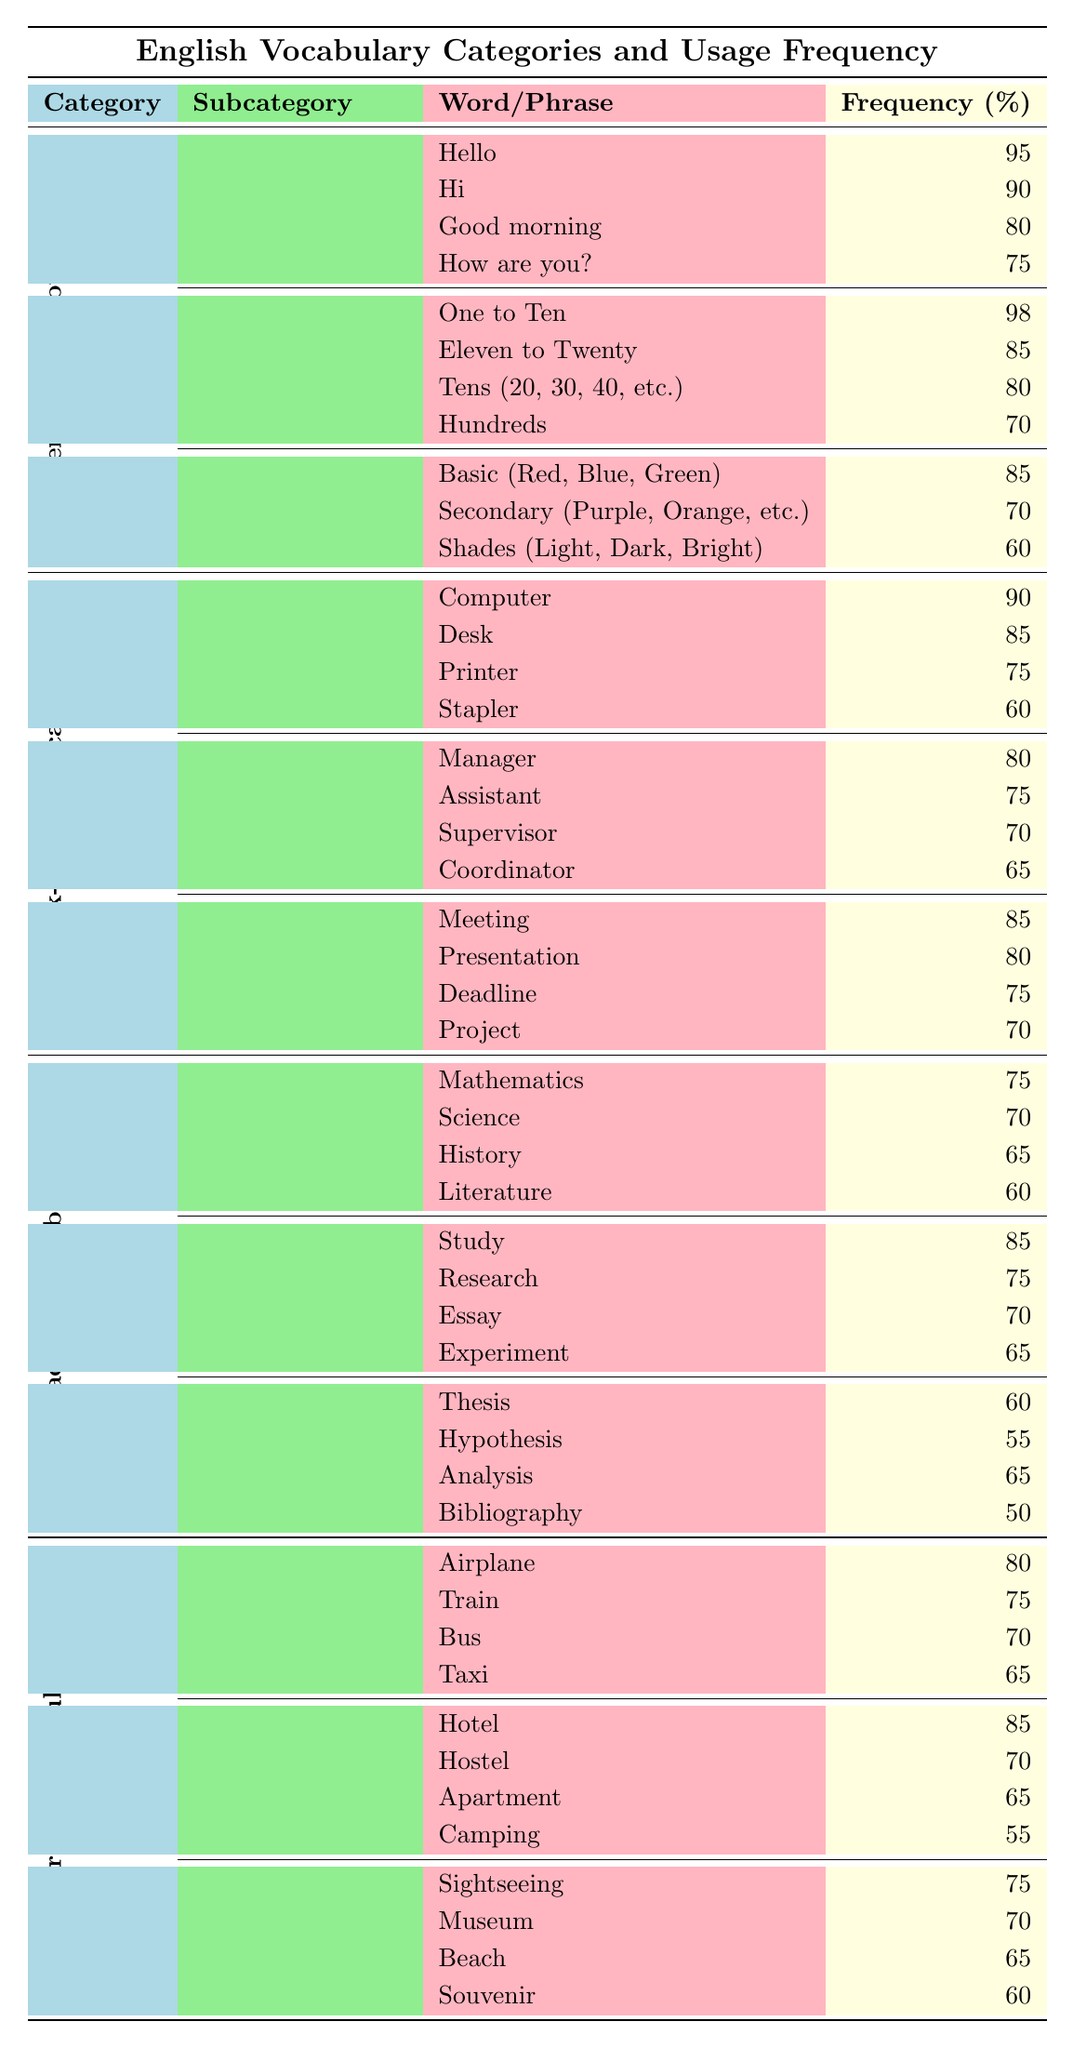What is the most frequently used word in the Everyday Vocabulary category? The highest frequency in the Everyday Vocabulary category is "One to Ten" with a frequency of 98%.
Answer: 98% How many words are listed under the Greetings subcategory? There are four words listed under the Greetings subcategory: Hello, Hi, Good morning, and How are you?.
Answer: 4 Which category has the highest frequency word for Office Items? The word "Computer" in the Office Items subcategory has the highest frequency at 90%.
Answer: 90% What is the frequency difference between the word "Thesis" and "Bibliography"? The frequency for "Thesis" is 60%, and for "Bibliography" it is 50%. Therefore, the difference is 60 - 50 = 10.
Answer: 10 Is "Organizer" listed as a Job Title in the Work-related Vocabulary category? "Organizer" is not listed among the Job Titles; the titles include Manager, Assistant, Supervisor, and Coordinator.
Answer: No What is the average frequency of colors in the Colors subcategory? The frequencies for colors are 85 (Basic), 70 (Secondary), and 60 (Shades). The average is (85 + 70 + 60) / 3 = 215 / 3 = 71.67.
Answer: 71.67 Which subcategory in Academic Vocabulary has the lowest frequency word? The Academic Terms subcategory has the lowest frequency word, "Bibliography," at 50%.
Answer: 50% In terms of Transportation, which word has a higher frequency, "Bus" or "Train"? The frequency for "Bus" is 70%, and for "Train," it is 75%. Since 75% (Train) is greater than 70% (Bus), "Train" has a higher frequency.
Answer: Train Count the total number of words listed in the Work-related Vocabulary category. There are 12 words total in the Work-related Vocabulary: 4 in Office Items, 4 in Job Titles, and 4 in Business Actions, making it (4 + 4 + 4) = 12 words.
Answer: 12 Which subcategory has the highest average frequency among all categories? The subcategory with the highest average frequency is "Everyday Vocabulary" with an average of (95 + 90 + 80 + 75 + 98 + 85 + 80 + 70 + 85 + 70 + 60) / 11 = 80.64.
Answer: Everyday Vocabulary 